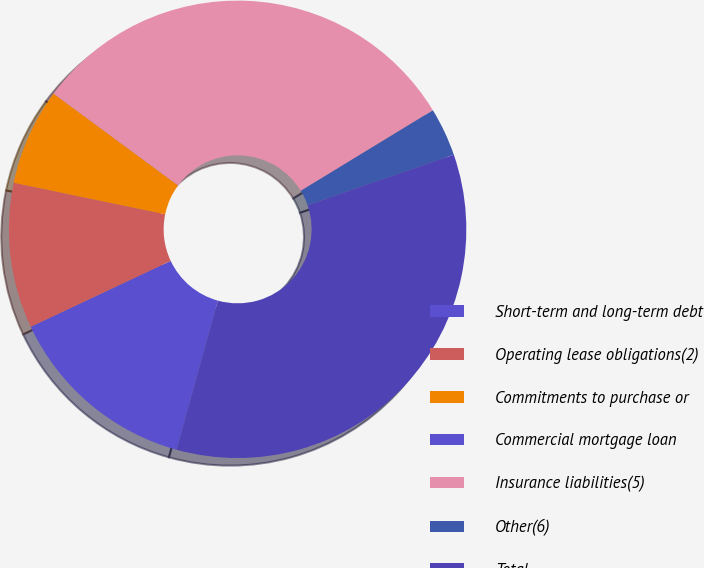<chart> <loc_0><loc_0><loc_500><loc_500><pie_chart><fcel>Short-term and long-term debt<fcel>Operating lease obligations(2)<fcel>Commitments to purchase or<fcel>Commercial mortgage loan<fcel>Insurance liabilities(5)<fcel>Other(6)<fcel>Total<nl><fcel>13.69%<fcel>10.27%<fcel>6.85%<fcel>0.0%<fcel>31.18%<fcel>3.42%<fcel>34.6%<nl></chart> 